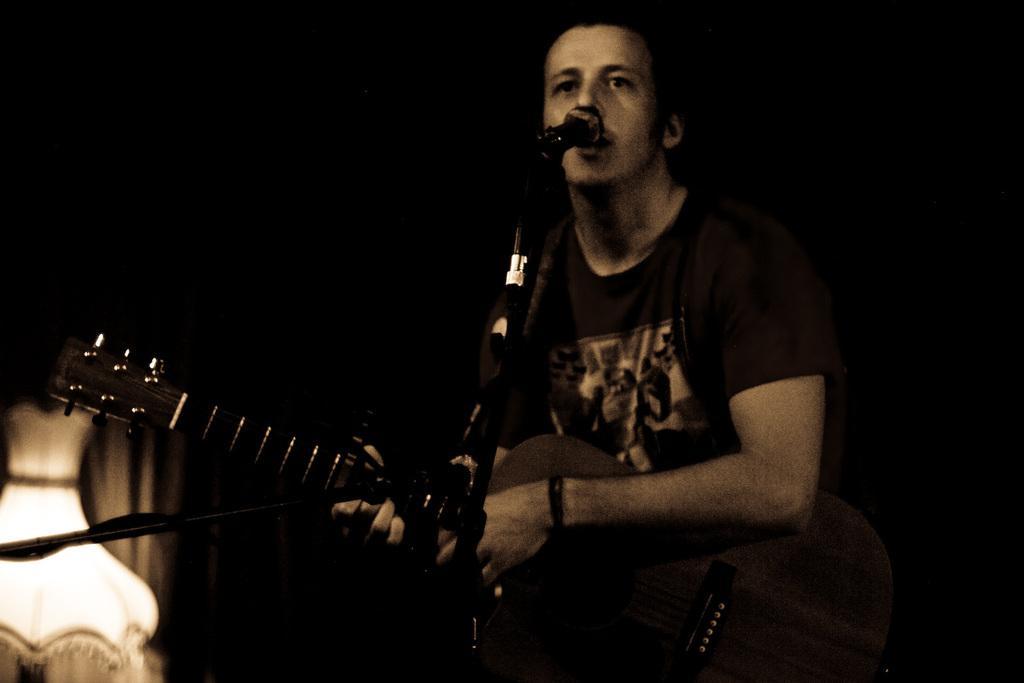How would you summarize this image in a sentence or two? Here a man is singing and playing guitar. 